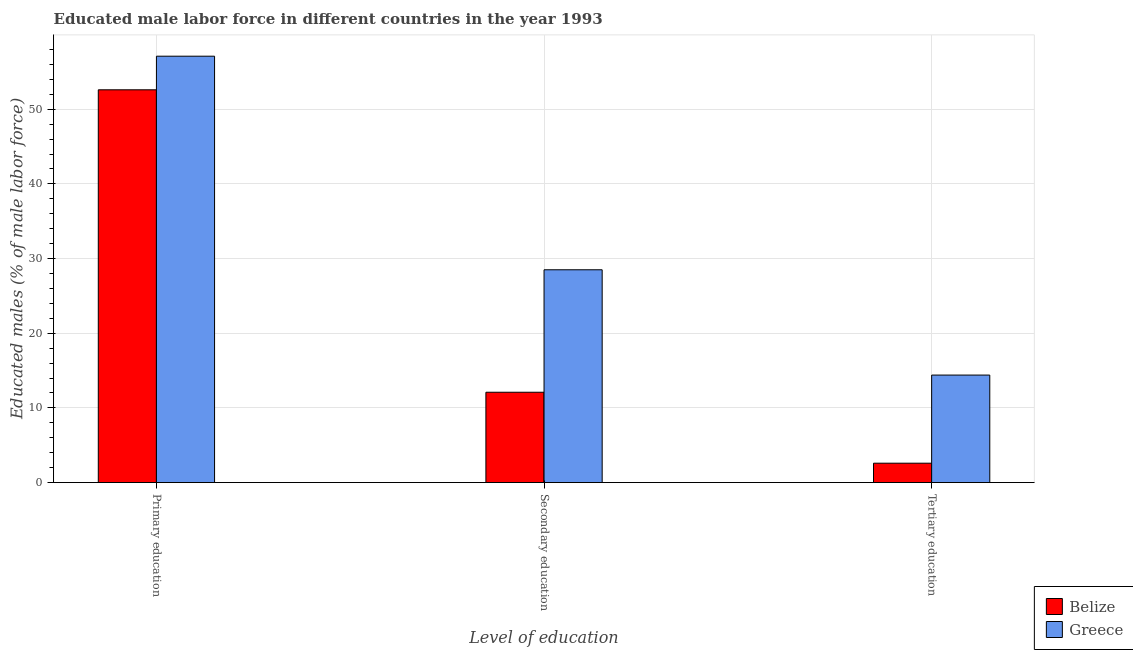How many groups of bars are there?
Your response must be concise. 3. Are the number of bars per tick equal to the number of legend labels?
Keep it short and to the point. Yes. How many bars are there on the 1st tick from the left?
Give a very brief answer. 2. How many bars are there on the 1st tick from the right?
Offer a very short reply. 2. What is the label of the 3rd group of bars from the left?
Offer a terse response. Tertiary education. What is the percentage of male labor force who received primary education in Belize?
Provide a short and direct response. 52.6. Across all countries, what is the maximum percentage of male labor force who received tertiary education?
Provide a succinct answer. 14.4. Across all countries, what is the minimum percentage of male labor force who received secondary education?
Your answer should be compact. 12.1. In which country was the percentage of male labor force who received primary education minimum?
Your response must be concise. Belize. What is the total percentage of male labor force who received primary education in the graph?
Your response must be concise. 109.7. What is the difference between the percentage of male labor force who received primary education in Greece and the percentage of male labor force who received secondary education in Belize?
Offer a terse response. 45. What is the average percentage of male labor force who received secondary education per country?
Keep it short and to the point. 20.3. What is the difference between the percentage of male labor force who received primary education and percentage of male labor force who received secondary education in Belize?
Offer a very short reply. 40.5. In how many countries, is the percentage of male labor force who received primary education greater than 38 %?
Your answer should be compact. 2. What is the ratio of the percentage of male labor force who received primary education in Belize to that in Greece?
Keep it short and to the point. 0.92. What is the difference between the highest and the second highest percentage of male labor force who received tertiary education?
Provide a short and direct response. 11.8. What is the difference between the highest and the lowest percentage of male labor force who received primary education?
Provide a short and direct response. 4.5. In how many countries, is the percentage of male labor force who received primary education greater than the average percentage of male labor force who received primary education taken over all countries?
Offer a very short reply. 1. Is the sum of the percentage of male labor force who received primary education in Belize and Greece greater than the maximum percentage of male labor force who received tertiary education across all countries?
Make the answer very short. Yes. What does the 1st bar from the left in Primary education represents?
Your answer should be compact. Belize. What does the 2nd bar from the right in Primary education represents?
Your response must be concise. Belize. Is it the case that in every country, the sum of the percentage of male labor force who received primary education and percentage of male labor force who received secondary education is greater than the percentage of male labor force who received tertiary education?
Offer a terse response. Yes. Are the values on the major ticks of Y-axis written in scientific E-notation?
Your response must be concise. No. Does the graph contain any zero values?
Give a very brief answer. No. Where does the legend appear in the graph?
Make the answer very short. Bottom right. How are the legend labels stacked?
Your answer should be compact. Vertical. What is the title of the graph?
Provide a succinct answer. Educated male labor force in different countries in the year 1993. What is the label or title of the X-axis?
Keep it short and to the point. Level of education. What is the label or title of the Y-axis?
Your answer should be compact. Educated males (% of male labor force). What is the Educated males (% of male labor force) in Belize in Primary education?
Give a very brief answer. 52.6. What is the Educated males (% of male labor force) in Greece in Primary education?
Your response must be concise. 57.1. What is the Educated males (% of male labor force) in Belize in Secondary education?
Give a very brief answer. 12.1. What is the Educated males (% of male labor force) in Greece in Secondary education?
Ensure brevity in your answer.  28.5. What is the Educated males (% of male labor force) in Belize in Tertiary education?
Offer a very short reply. 2.6. What is the Educated males (% of male labor force) of Greece in Tertiary education?
Offer a terse response. 14.4. Across all Level of education, what is the maximum Educated males (% of male labor force) in Belize?
Provide a short and direct response. 52.6. Across all Level of education, what is the maximum Educated males (% of male labor force) in Greece?
Give a very brief answer. 57.1. Across all Level of education, what is the minimum Educated males (% of male labor force) of Belize?
Offer a very short reply. 2.6. Across all Level of education, what is the minimum Educated males (% of male labor force) in Greece?
Give a very brief answer. 14.4. What is the total Educated males (% of male labor force) in Belize in the graph?
Your answer should be compact. 67.3. What is the total Educated males (% of male labor force) in Greece in the graph?
Offer a terse response. 100. What is the difference between the Educated males (% of male labor force) of Belize in Primary education and that in Secondary education?
Your answer should be compact. 40.5. What is the difference between the Educated males (% of male labor force) of Greece in Primary education and that in Secondary education?
Ensure brevity in your answer.  28.6. What is the difference between the Educated males (% of male labor force) in Belize in Primary education and that in Tertiary education?
Provide a succinct answer. 50. What is the difference between the Educated males (% of male labor force) of Greece in Primary education and that in Tertiary education?
Offer a terse response. 42.7. What is the difference between the Educated males (% of male labor force) in Greece in Secondary education and that in Tertiary education?
Make the answer very short. 14.1. What is the difference between the Educated males (% of male labor force) in Belize in Primary education and the Educated males (% of male labor force) in Greece in Secondary education?
Provide a short and direct response. 24.1. What is the difference between the Educated males (% of male labor force) of Belize in Primary education and the Educated males (% of male labor force) of Greece in Tertiary education?
Your answer should be very brief. 38.2. What is the difference between the Educated males (% of male labor force) of Belize in Secondary education and the Educated males (% of male labor force) of Greece in Tertiary education?
Provide a short and direct response. -2.3. What is the average Educated males (% of male labor force) of Belize per Level of education?
Your answer should be compact. 22.43. What is the average Educated males (% of male labor force) in Greece per Level of education?
Your answer should be compact. 33.33. What is the difference between the Educated males (% of male labor force) in Belize and Educated males (% of male labor force) in Greece in Secondary education?
Give a very brief answer. -16.4. What is the difference between the Educated males (% of male labor force) in Belize and Educated males (% of male labor force) in Greece in Tertiary education?
Ensure brevity in your answer.  -11.8. What is the ratio of the Educated males (% of male labor force) of Belize in Primary education to that in Secondary education?
Your answer should be compact. 4.35. What is the ratio of the Educated males (% of male labor force) in Greece in Primary education to that in Secondary education?
Your response must be concise. 2. What is the ratio of the Educated males (% of male labor force) in Belize in Primary education to that in Tertiary education?
Your answer should be compact. 20.23. What is the ratio of the Educated males (% of male labor force) in Greece in Primary education to that in Tertiary education?
Ensure brevity in your answer.  3.97. What is the ratio of the Educated males (% of male labor force) in Belize in Secondary education to that in Tertiary education?
Your response must be concise. 4.65. What is the ratio of the Educated males (% of male labor force) of Greece in Secondary education to that in Tertiary education?
Offer a terse response. 1.98. What is the difference between the highest and the second highest Educated males (% of male labor force) of Belize?
Your answer should be very brief. 40.5. What is the difference between the highest and the second highest Educated males (% of male labor force) of Greece?
Your answer should be compact. 28.6. What is the difference between the highest and the lowest Educated males (% of male labor force) in Greece?
Your answer should be very brief. 42.7. 